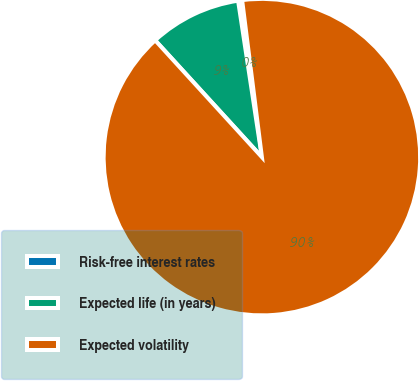<chart> <loc_0><loc_0><loc_500><loc_500><pie_chart><fcel>Risk-free interest rates<fcel>Expected life (in years)<fcel>Expected volatility<nl><fcel>0.41%<fcel>9.38%<fcel>90.21%<nl></chart> 